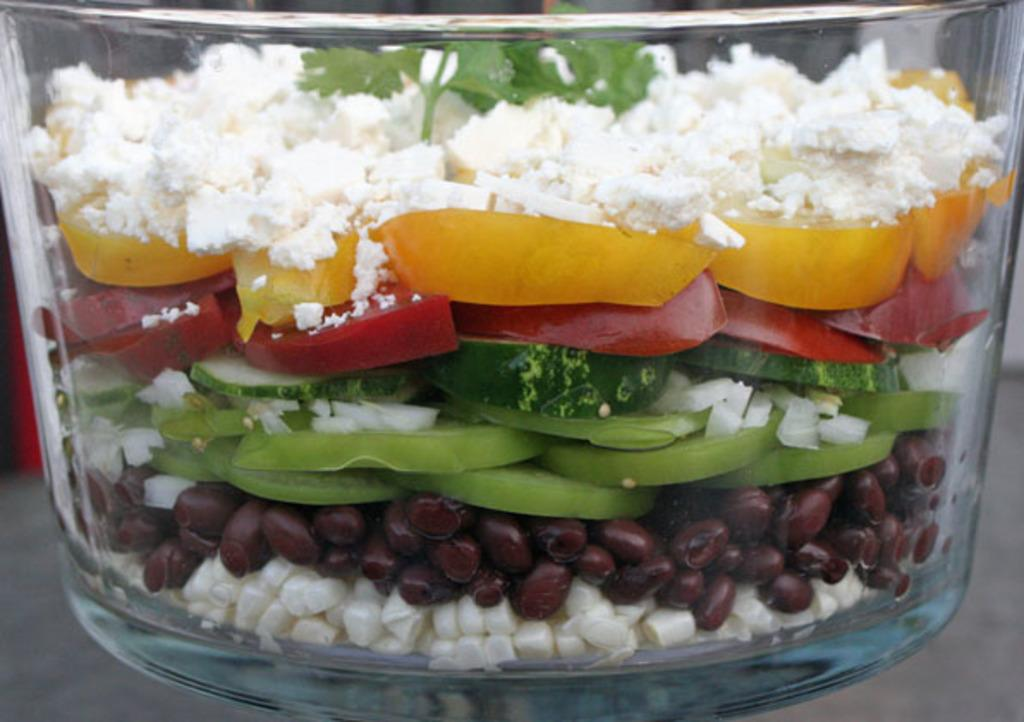What type of container is visible in the image? There is a glass container in the image. What is inside the glass container? Food is present inside the glass container. Can you describe the appearance of the food? The food has various colors, including white, green, yellow, red, and brown. What type of balls can be seen bouncing around inside the glass container? There are no balls present inside the glass container; it contains food with various colors. 